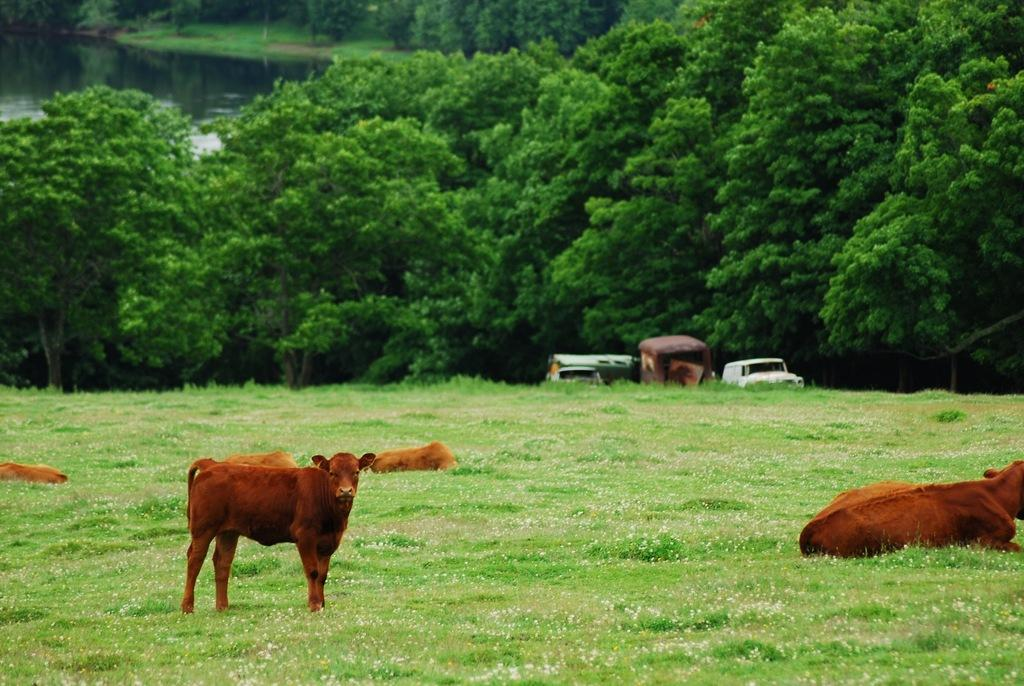What type of animals can be seen in the image? There are animals in the grass in the image. What natural elements are present in the image? Trees are present around the grass, and there is a river visible in the image. What can be seen in the background of the image? Vehicles are in the background of the image. What type of school can be seen in the image? There is no school present in the image; it features animals in the grass, trees, a river, and vehicles in the background. Can you tell me how many jail cells are visible in the image? There are no jail cells present in the image; it features animals in the grass, trees, a river, and vehicles in the background. 